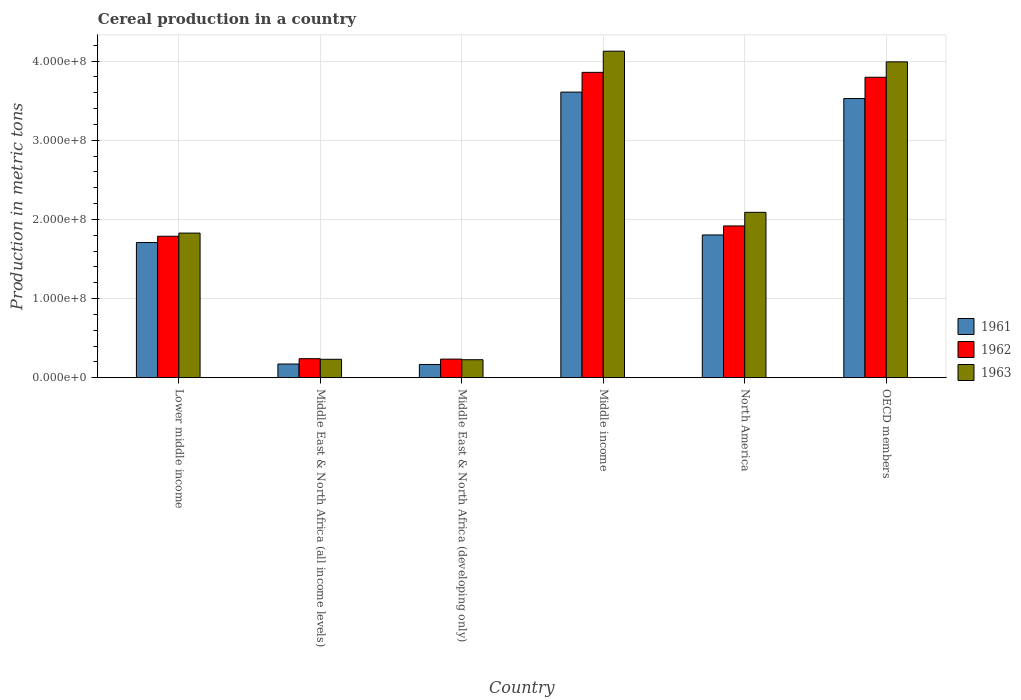How many groups of bars are there?
Provide a succinct answer. 6. Are the number of bars on each tick of the X-axis equal?
Provide a succinct answer. Yes. How many bars are there on the 5th tick from the left?
Your answer should be very brief. 3. What is the total cereal production in 1963 in Middle East & North Africa (all income levels)?
Provide a short and direct response. 2.32e+07. Across all countries, what is the maximum total cereal production in 1963?
Your answer should be compact. 4.13e+08. Across all countries, what is the minimum total cereal production in 1962?
Your response must be concise. 2.35e+07. In which country was the total cereal production in 1961 minimum?
Ensure brevity in your answer.  Middle East & North Africa (developing only). What is the total total cereal production in 1962 in the graph?
Your answer should be very brief. 1.18e+09. What is the difference between the total cereal production in 1963 in Middle East & North Africa (all income levels) and that in Middle East & North Africa (developing only)?
Offer a very short reply. 5.41e+05. What is the difference between the total cereal production in 1962 in Middle East & North Africa (all income levels) and the total cereal production in 1961 in Middle East & North Africa (developing only)?
Ensure brevity in your answer.  7.29e+06. What is the average total cereal production in 1962 per country?
Give a very brief answer. 1.97e+08. What is the difference between the total cereal production of/in 1962 and total cereal production of/in 1963 in Middle East & North Africa (developing only)?
Offer a terse response. 7.80e+05. What is the ratio of the total cereal production in 1963 in Middle East & North Africa (developing only) to that in Middle income?
Provide a succinct answer. 0.05. Is the difference between the total cereal production in 1962 in Middle East & North Africa (all income levels) and Middle East & North Africa (developing only) greater than the difference between the total cereal production in 1963 in Middle East & North Africa (all income levels) and Middle East & North Africa (developing only)?
Make the answer very short. No. What is the difference between the highest and the second highest total cereal production in 1962?
Your answer should be very brief. 6.21e+06. What is the difference between the highest and the lowest total cereal production in 1961?
Your response must be concise. 3.44e+08. In how many countries, is the total cereal production in 1962 greater than the average total cereal production in 1962 taken over all countries?
Provide a succinct answer. 2. Is the sum of the total cereal production in 1962 in Middle East & North Africa (all income levels) and OECD members greater than the maximum total cereal production in 1963 across all countries?
Give a very brief answer. No. What does the 3rd bar from the left in OECD members represents?
Keep it short and to the point. 1963. What does the 2nd bar from the right in Middle East & North Africa (all income levels) represents?
Offer a terse response. 1962. Are all the bars in the graph horizontal?
Ensure brevity in your answer.  No. How many countries are there in the graph?
Ensure brevity in your answer.  6. Does the graph contain grids?
Make the answer very short. Yes. How many legend labels are there?
Ensure brevity in your answer.  3. How are the legend labels stacked?
Provide a short and direct response. Vertical. What is the title of the graph?
Give a very brief answer. Cereal production in a country. What is the label or title of the X-axis?
Provide a short and direct response. Country. What is the label or title of the Y-axis?
Offer a terse response. Production in metric tons. What is the Production in metric tons in 1961 in Lower middle income?
Make the answer very short. 1.71e+08. What is the Production in metric tons in 1962 in Lower middle income?
Provide a short and direct response. 1.79e+08. What is the Production in metric tons in 1963 in Lower middle income?
Give a very brief answer. 1.83e+08. What is the Production in metric tons of 1961 in Middle East & North Africa (all income levels)?
Provide a short and direct response. 1.72e+07. What is the Production in metric tons in 1962 in Middle East & North Africa (all income levels)?
Give a very brief answer. 2.40e+07. What is the Production in metric tons of 1963 in Middle East & North Africa (all income levels)?
Offer a very short reply. 2.32e+07. What is the Production in metric tons of 1961 in Middle East & North Africa (developing only)?
Offer a very short reply. 1.67e+07. What is the Production in metric tons in 1962 in Middle East & North Africa (developing only)?
Keep it short and to the point. 2.35e+07. What is the Production in metric tons of 1963 in Middle East & North Africa (developing only)?
Your response must be concise. 2.27e+07. What is the Production in metric tons in 1961 in Middle income?
Your answer should be compact. 3.61e+08. What is the Production in metric tons of 1962 in Middle income?
Your answer should be compact. 3.86e+08. What is the Production in metric tons in 1963 in Middle income?
Give a very brief answer. 4.13e+08. What is the Production in metric tons in 1961 in North America?
Provide a succinct answer. 1.80e+08. What is the Production in metric tons of 1962 in North America?
Offer a terse response. 1.92e+08. What is the Production in metric tons in 1963 in North America?
Give a very brief answer. 2.09e+08. What is the Production in metric tons in 1961 in OECD members?
Your answer should be compact. 3.53e+08. What is the Production in metric tons in 1962 in OECD members?
Your response must be concise. 3.80e+08. What is the Production in metric tons of 1963 in OECD members?
Offer a terse response. 3.99e+08. Across all countries, what is the maximum Production in metric tons of 1961?
Offer a very short reply. 3.61e+08. Across all countries, what is the maximum Production in metric tons in 1962?
Ensure brevity in your answer.  3.86e+08. Across all countries, what is the maximum Production in metric tons of 1963?
Your answer should be very brief. 4.13e+08. Across all countries, what is the minimum Production in metric tons of 1961?
Provide a short and direct response. 1.67e+07. Across all countries, what is the minimum Production in metric tons in 1962?
Provide a short and direct response. 2.35e+07. Across all countries, what is the minimum Production in metric tons of 1963?
Provide a short and direct response. 2.27e+07. What is the total Production in metric tons of 1961 in the graph?
Your answer should be compact. 1.10e+09. What is the total Production in metric tons of 1962 in the graph?
Provide a short and direct response. 1.18e+09. What is the total Production in metric tons in 1963 in the graph?
Offer a very short reply. 1.25e+09. What is the difference between the Production in metric tons in 1961 in Lower middle income and that in Middle East & North Africa (all income levels)?
Ensure brevity in your answer.  1.54e+08. What is the difference between the Production in metric tons in 1962 in Lower middle income and that in Middle East & North Africa (all income levels)?
Keep it short and to the point. 1.55e+08. What is the difference between the Production in metric tons in 1963 in Lower middle income and that in Middle East & North Africa (all income levels)?
Ensure brevity in your answer.  1.59e+08. What is the difference between the Production in metric tons of 1961 in Lower middle income and that in Middle East & North Africa (developing only)?
Offer a very short reply. 1.54e+08. What is the difference between the Production in metric tons in 1962 in Lower middle income and that in Middle East & North Africa (developing only)?
Offer a terse response. 1.55e+08. What is the difference between the Production in metric tons of 1963 in Lower middle income and that in Middle East & North Africa (developing only)?
Your response must be concise. 1.60e+08. What is the difference between the Production in metric tons in 1961 in Lower middle income and that in Middle income?
Offer a very short reply. -1.90e+08. What is the difference between the Production in metric tons in 1962 in Lower middle income and that in Middle income?
Your answer should be compact. -2.07e+08. What is the difference between the Production in metric tons of 1963 in Lower middle income and that in Middle income?
Your response must be concise. -2.30e+08. What is the difference between the Production in metric tons of 1961 in Lower middle income and that in North America?
Offer a very short reply. -9.59e+06. What is the difference between the Production in metric tons of 1962 in Lower middle income and that in North America?
Your response must be concise. -1.30e+07. What is the difference between the Production in metric tons of 1963 in Lower middle income and that in North America?
Your response must be concise. -2.62e+07. What is the difference between the Production in metric tons in 1961 in Lower middle income and that in OECD members?
Keep it short and to the point. -1.82e+08. What is the difference between the Production in metric tons in 1962 in Lower middle income and that in OECD members?
Give a very brief answer. -2.01e+08. What is the difference between the Production in metric tons in 1963 in Lower middle income and that in OECD members?
Give a very brief answer. -2.16e+08. What is the difference between the Production in metric tons of 1961 in Middle East & North Africa (all income levels) and that in Middle East & North Africa (developing only)?
Your response must be concise. 5.40e+05. What is the difference between the Production in metric tons in 1962 in Middle East & North Africa (all income levels) and that in Middle East & North Africa (developing only)?
Ensure brevity in your answer.  5.21e+05. What is the difference between the Production in metric tons of 1963 in Middle East & North Africa (all income levels) and that in Middle East & North Africa (developing only)?
Provide a short and direct response. 5.41e+05. What is the difference between the Production in metric tons of 1961 in Middle East & North Africa (all income levels) and that in Middle income?
Your answer should be compact. -3.44e+08. What is the difference between the Production in metric tons of 1962 in Middle East & North Africa (all income levels) and that in Middle income?
Your answer should be very brief. -3.62e+08. What is the difference between the Production in metric tons in 1963 in Middle East & North Africa (all income levels) and that in Middle income?
Offer a very short reply. -3.89e+08. What is the difference between the Production in metric tons in 1961 in Middle East & North Africa (all income levels) and that in North America?
Offer a terse response. -1.63e+08. What is the difference between the Production in metric tons in 1962 in Middle East & North Africa (all income levels) and that in North America?
Give a very brief answer. -1.68e+08. What is the difference between the Production in metric tons of 1963 in Middle East & North Africa (all income levels) and that in North America?
Make the answer very short. -1.86e+08. What is the difference between the Production in metric tons of 1961 in Middle East & North Africa (all income levels) and that in OECD members?
Give a very brief answer. -3.35e+08. What is the difference between the Production in metric tons of 1962 in Middle East & North Africa (all income levels) and that in OECD members?
Ensure brevity in your answer.  -3.56e+08. What is the difference between the Production in metric tons in 1963 in Middle East & North Africa (all income levels) and that in OECD members?
Offer a terse response. -3.76e+08. What is the difference between the Production in metric tons in 1961 in Middle East & North Africa (developing only) and that in Middle income?
Your response must be concise. -3.44e+08. What is the difference between the Production in metric tons of 1962 in Middle East & North Africa (developing only) and that in Middle income?
Keep it short and to the point. -3.62e+08. What is the difference between the Production in metric tons in 1963 in Middle East & North Africa (developing only) and that in Middle income?
Provide a short and direct response. -3.90e+08. What is the difference between the Production in metric tons in 1961 in Middle East & North Africa (developing only) and that in North America?
Offer a very short reply. -1.64e+08. What is the difference between the Production in metric tons of 1962 in Middle East & North Africa (developing only) and that in North America?
Keep it short and to the point. -1.68e+08. What is the difference between the Production in metric tons of 1963 in Middle East & North Africa (developing only) and that in North America?
Offer a terse response. -1.86e+08. What is the difference between the Production in metric tons of 1961 in Middle East & North Africa (developing only) and that in OECD members?
Make the answer very short. -3.36e+08. What is the difference between the Production in metric tons of 1962 in Middle East & North Africa (developing only) and that in OECD members?
Ensure brevity in your answer.  -3.56e+08. What is the difference between the Production in metric tons of 1963 in Middle East & North Africa (developing only) and that in OECD members?
Your response must be concise. -3.76e+08. What is the difference between the Production in metric tons in 1961 in Middle income and that in North America?
Offer a very short reply. 1.81e+08. What is the difference between the Production in metric tons in 1962 in Middle income and that in North America?
Give a very brief answer. 1.94e+08. What is the difference between the Production in metric tons in 1963 in Middle income and that in North America?
Offer a very short reply. 2.04e+08. What is the difference between the Production in metric tons in 1961 in Middle income and that in OECD members?
Provide a short and direct response. 8.13e+06. What is the difference between the Production in metric tons of 1962 in Middle income and that in OECD members?
Your answer should be very brief. 6.21e+06. What is the difference between the Production in metric tons of 1963 in Middle income and that in OECD members?
Keep it short and to the point. 1.35e+07. What is the difference between the Production in metric tons of 1961 in North America and that in OECD members?
Offer a terse response. -1.72e+08. What is the difference between the Production in metric tons in 1962 in North America and that in OECD members?
Give a very brief answer. -1.88e+08. What is the difference between the Production in metric tons in 1963 in North America and that in OECD members?
Your answer should be very brief. -1.90e+08. What is the difference between the Production in metric tons of 1961 in Lower middle income and the Production in metric tons of 1962 in Middle East & North Africa (all income levels)?
Offer a terse response. 1.47e+08. What is the difference between the Production in metric tons in 1961 in Lower middle income and the Production in metric tons in 1963 in Middle East & North Africa (all income levels)?
Your answer should be compact. 1.48e+08. What is the difference between the Production in metric tons of 1962 in Lower middle income and the Production in metric tons of 1963 in Middle East & North Africa (all income levels)?
Provide a succinct answer. 1.55e+08. What is the difference between the Production in metric tons of 1961 in Lower middle income and the Production in metric tons of 1962 in Middle East & North Africa (developing only)?
Provide a short and direct response. 1.47e+08. What is the difference between the Production in metric tons of 1961 in Lower middle income and the Production in metric tons of 1963 in Middle East & North Africa (developing only)?
Give a very brief answer. 1.48e+08. What is the difference between the Production in metric tons of 1962 in Lower middle income and the Production in metric tons of 1963 in Middle East & North Africa (developing only)?
Your answer should be compact. 1.56e+08. What is the difference between the Production in metric tons of 1961 in Lower middle income and the Production in metric tons of 1962 in Middle income?
Offer a very short reply. -2.15e+08. What is the difference between the Production in metric tons in 1961 in Lower middle income and the Production in metric tons in 1963 in Middle income?
Provide a succinct answer. -2.42e+08. What is the difference between the Production in metric tons of 1962 in Lower middle income and the Production in metric tons of 1963 in Middle income?
Make the answer very short. -2.34e+08. What is the difference between the Production in metric tons in 1961 in Lower middle income and the Production in metric tons in 1962 in North America?
Your answer should be compact. -2.10e+07. What is the difference between the Production in metric tons of 1961 in Lower middle income and the Production in metric tons of 1963 in North America?
Your answer should be compact. -3.82e+07. What is the difference between the Production in metric tons in 1962 in Lower middle income and the Production in metric tons in 1963 in North America?
Your answer should be very brief. -3.02e+07. What is the difference between the Production in metric tons of 1961 in Lower middle income and the Production in metric tons of 1962 in OECD members?
Your answer should be very brief. -2.09e+08. What is the difference between the Production in metric tons in 1961 in Lower middle income and the Production in metric tons in 1963 in OECD members?
Your answer should be compact. -2.28e+08. What is the difference between the Production in metric tons in 1962 in Lower middle income and the Production in metric tons in 1963 in OECD members?
Keep it short and to the point. -2.20e+08. What is the difference between the Production in metric tons in 1961 in Middle East & North Africa (all income levels) and the Production in metric tons in 1962 in Middle East & North Africa (developing only)?
Ensure brevity in your answer.  -6.23e+06. What is the difference between the Production in metric tons of 1961 in Middle East & North Africa (all income levels) and the Production in metric tons of 1963 in Middle East & North Africa (developing only)?
Your answer should be very brief. -5.45e+06. What is the difference between the Production in metric tons of 1962 in Middle East & North Africa (all income levels) and the Production in metric tons of 1963 in Middle East & North Africa (developing only)?
Provide a succinct answer. 1.30e+06. What is the difference between the Production in metric tons of 1961 in Middle East & North Africa (all income levels) and the Production in metric tons of 1962 in Middle income?
Ensure brevity in your answer.  -3.69e+08. What is the difference between the Production in metric tons in 1961 in Middle East & North Africa (all income levels) and the Production in metric tons in 1963 in Middle income?
Make the answer very short. -3.95e+08. What is the difference between the Production in metric tons of 1962 in Middle East & North Africa (all income levels) and the Production in metric tons of 1963 in Middle income?
Provide a short and direct response. -3.89e+08. What is the difference between the Production in metric tons of 1961 in Middle East & North Africa (all income levels) and the Production in metric tons of 1962 in North America?
Your answer should be very brief. -1.74e+08. What is the difference between the Production in metric tons in 1961 in Middle East & North Africa (all income levels) and the Production in metric tons in 1963 in North America?
Make the answer very short. -1.92e+08. What is the difference between the Production in metric tons in 1962 in Middle East & North Africa (all income levels) and the Production in metric tons in 1963 in North America?
Offer a very short reply. -1.85e+08. What is the difference between the Production in metric tons in 1961 in Middle East & North Africa (all income levels) and the Production in metric tons in 1962 in OECD members?
Your response must be concise. -3.62e+08. What is the difference between the Production in metric tons in 1961 in Middle East & North Africa (all income levels) and the Production in metric tons in 1963 in OECD members?
Provide a short and direct response. -3.82e+08. What is the difference between the Production in metric tons of 1962 in Middle East & North Africa (all income levels) and the Production in metric tons of 1963 in OECD members?
Provide a succinct answer. -3.75e+08. What is the difference between the Production in metric tons in 1961 in Middle East & North Africa (developing only) and the Production in metric tons in 1962 in Middle income?
Ensure brevity in your answer.  -3.69e+08. What is the difference between the Production in metric tons in 1961 in Middle East & North Africa (developing only) and the Production in metric tons in 1963 in Middle income?
Make the answer very short. -3.96e+08. What is the difference between the Production in metric tons of 1962 in Middle East & North Africa (developing only) and the Production in metric tons of 1963 in Middle income?
Your answer should be compact. -3.89e+08. What is the difference between the Production in metric tons of 1961 in Middle East & North Africa (developing only) and the Production in metric tons of 1962 in North America?
Ensure brevity in your answer.  -1.75e+08. What is the difference between the Production in metric tons in 1961 in Middle East & North Africa (developing only) and the Production in metric tons in 1963 in North America?
Your answer should be very brief. -1.92e+08. What is the difference between the Production in metric tons in 1962 in Middle East & North Africa (developing only) and the Production in metric tons in 1963 in North America?
Your answer should be compact. -1.85e+08. What is the difference between the Production in metric tons in 1961 in Middle East & North Africa (developing only) and the Production in metric tons in 1962 in OECD members?
Provide a succinct answer. -3.63e+08. What is the difference between the Production in metric tons of 1961 in Middle East & North Africa (developing only) and the Production in metric tons of 1963 in OECD members?
Provide a short and direct response. -3.82e+08. What is the difference between the Production in metric tons of 1962 in Middle East & North Africa (developing only) and the Production in metric tons of 1963 in OECD members?
Ensure brevity in your answer.  -3.76e+08. What is the difference between the Production in metric tons of 1961 in Middle income and the Production in metric tons of 1962 in North America?
Offer a terse response. 1.69e+08. What is the difference between the Production in metric tons of 1961 in Middle income and the Production in metric tons of 1963 in North America?
Give a very brief answer. 1.52e+08. What is the difference between the Production in metric tons of 1962 in Middle income and the Production in metric tons of 1963 in North America?
Give a very brief answer. 1.77e+08. What is the difference between the Production in metric tons of 1961 in Middle income and the Production in metric tons of 1962 in OECD members?
Provide a succinct answer. -1.88e+07. What is the difference between the Production in metric tons in 1961 in Middle income and the Production in metric tons in 1963 in OECD members?
Offer a terse response. -3.82e+07. What is the difference between the Production in metric tons in 1962 in Middle income and the Production in metric tons in 1963 in OECD members?
Offer a very short reply. -1.32e+07. What is the difference between the Production in metric tons in 1961 in North America and the Production in metric tons in 1962 in OECD members?
Offer a very short reply. -1.99e+08. What is the difference between the Production in metric tons of 1961 in North America and the Production in metric tons of 1963 in OECD members?
Keep it short and to the point. -2.19e+08. What is the difference between the Production in metric tons of 1962 in North America and the Production in metric tons of 1963 in OECD members?
Your answer should be compact. -2.07e+08. What is the average Production in metric tons of 1961 per country?
Ensure brevity in your answer.  1.83e+08. What is the average Production in metric tons of 1962 per country?
Keep it short and to the point. 1.97e+08. What is the average Production in metric tons in 1963 per country?
Make the answer very short. 2.08e+08. What is the difference between the Production in metric tons of 1961 and Production in metric tons of 1962 in Lower middle income?
Make the answer very short. -7.94e+06. What is the difference between the Production in metric tons in 1961 and Production in metric tons in 1963 in Lower middle income?
Provide a short and direct response. -1.19e+07. What is the difference between the Production in metric tons in 1962 and Production in metric tons in 1963 in Lower middle income?
Make the answer very short. -4.00e+06. What is the difference between the Production in metric tons in 1961 and Production in metric tons in 1962 in Middle East & North Africa (all income levels)?
Provide a short and direct response. -6.75e+06. What is the difference between the Production in metric tons of 1961 and Production in metric tons of 1963 in Middle East & North Africa (all income levels)?
Make the answer very short. -5.99e+06. What is the difference between the Production in metric tons of 1962 and Production in metric tons of 1963 in Middle East & North Africa (all income levels)?
Offer a very short reply. 7.60e+05. What is the difference between the Production in metric tons of 1961 and Production in metric tons of 1962 in Middle East & North Africa (developing only)?
Give a very brief answer. -6.77e+06. What is the difference between the Production in metric tons in 1961 and Production in metric tons in 1963 in Middle East & North Africa (developing only)?
Keep it short and to the point. -5.99e+06. What is the difference between the Production in metric tons of 1962 and Production in metric tons of 1963 in Middle East & North Africa (developing only)?
Your response must be concise. 7.80e+05. What is the difference between the Production in metric tons in 1961 and Production in metric tons in 1962 in Middle income?
Offer a terse response. -2.50e+07. What is the difference between the Production in metric tons in 1961 and Production in metric tons in 1963 in Middle income?
Make the answer very short. -5.17e+07. What is the difference between the Production in metric tons of 1962 and Production in metric tons of 1963 in Middle income?
Provide a succinct answer. -2.67e+07. What is the difference between the Production in metric tons in 1961 and Production in metric tons in 1962 in North America?
Ensure brevity in your answer.  -1.14e+07. What is the difference between the Production in metric tons in 1961 and Production in metric tons in 1963 in North America?
Your response must be concise. -2.86e+07. What is the difference between the Production in metric tons of 1962 and Production in metric tons of 1963 in North America?
Provide a succinct answer. -1.72e+07. What is the difference between the Production in metric tons in 1961 and Production in metric tons in 1962 in OECD members?
Provide a short and direct response. -2.69e+07. What is the difference between the Production in metric tons in 1961 and Production in metric tons in 1963 in OECD members?
Your answer should be very brief. -4.63e+07. What is the difference between the Production in metric tons of 1962 and Production in metric tons of 1963 in OECD members?
Your answer should be very brief. -1.94e+07. What is the ratio of the Production in metric tons in 1961 in Lower middle income to that in Middle East & North Africa (all income levels)?
Provide a short and direct response. 9.91. What is the ratio of the Production in metric tons in 1962 in Lower middle income to that in Middle East & North Africa (all income levels)?
Provide a short and direct response. 7.45. What is the ratio of the Production in metric tons of 1963 in Lower middle income to that in Middle East & North Africa (all income levels)?
Provide a short and direct response. 7.87. What is the ratio of the Production in metric tons in 1961 in Lower middle income to that in Middle East & North Africa (developing only)?
Your answer should be compact. 10.23. What is the ratio of the Production in metric tons in 1962 in Lower middle income to that in Middle East & North Africa (developing only)?
Ensure brevity in your answer.  7.62. What is the ratio of the Production in metric tons of 1963 in Lower middle income to that in Middle East & North Africa (developing only)?
Keep it short and to the point. 8.06. What is the ratio of the Production in metric tons in 1961 in Lower middle income to that in Middle income?
Offer a very short reply. 0.47. What is the ratio of the Production in metric tons of 1962 in Lower middle income to that in Middle income?
Your answer should be very brief. 0.46. What is the ratio of the Production in metric tons of 1963 in Lower middle income to that in Middle income?
Ensure brevity in your answer.  0.44. What is the ratio of the Production in metric tons of 1961 in Lower middle income to that in North America?
Provide a succinct answer. 0.95. What is the ratio of the Production in metric tons in 1962 in Lower middle income to that in North America?
Offer a very short reply. 0.93. What is the ratio of the Production in metric tons of 1963 in Lower middle income to that in North America?
Give a very brief answer. 0.87. What is the ratio of the Production in metric tons of 1961 in Lower middle income to that in OECD members?
Provide a short and direct response. 0.48. What is the ratio of the Production in metric tons of 1962 in Lower middle income to that in OECD members?
Offer a very short reply. 0.47. What is the ratio of the Production in metric tons in 1963 in Lower middle income to that in OECD members?
Provide a succinct answer. 0.46. What is the ratio of the Production in metric tons in 1961 in Middle East & North Africa (all income levels) to that in Middle East & North Africa (developing only)?
Offer a very short reply. 1.03. What is the ratio of the Production in metric tons of 1962 in Middle East & North Africa (all income levels) to that in Middle East & North Africa (developing only)?
Provide a succinct answer. 1.02. What is the ratio of the Production in metric tons in 1963 in Middle East & North Africa (all income levels) to that in Middle East & North Africa (developing only)?
Keep it short and to the point. 1.02. What is the ratio of the Production in metric tons of 1961 in Middle East & North Africa (all income levels) to that in Middle income?
Your answer should be very brief. 0.05. What is the ratio of the Production in metric tons in 1962 in Middle East & North Africa (all income levels) to that in Middle income?
Your answer should be compact. 0.06. What is the ratio of the Production in metric tons in 1963 in Middle East & North Africa (all income levels) to that in Middle income?
Give a very brief answer. 0.06. What is the ratio of the Production in metric tons in 1961 in Middle East & North Africa (all income levels) to that in North America?
Provide a short and direct response. 0.1. What is the ratio of the Production in metric tons in 1962 in Middle East & North Africa (all income levels) to that in North America?
Provide a succinct answer. 0.13. What is the ratio of the Production in metric tons of 1961 in Middle East & North Africa (all income levels) to that in OECD members?
Make the answer very short. 0.05. What is the ratio of the Production in metric tons of 1962 in Middle East & North Africa (all income levels) to that in OECD members?
Your response must be concise. 0.06. What is the ratio of the Production in metric tons in 1963 in Middle East & North Africa (all income levels) to that in OECD members?
Make the answer very short. 0.06. What is the ratio of the Production in metric tons in 1961 in Middle East & North Africa (developing only) to that in Middle income?
Your answer should be compact. 0.05. What is the ratio of the Production in metric tons of 1962 in Middle East & North Africa (developing only) to that in Middle income?
Your answer should be very brief. 0.06. What is the ratio of the Production in metric tons in 1963 in Middle East & North Africa (developing only) to that in Middle income?
Offer a very short reply. 0.06. What is the ratio of the Production in metric tons of 1961 in Middle East & North Africa (developing only) to that in North America?
Your response must be concise. 0.09. What is the ratio of the Production in metric tons in 1962 in Middle East & North Africa (developing only) to that in North America?
Your answer should be very brief. 0.12. What is the ratio of the Production in metric tons of 1963 in Middle East & North Africa (developing only) to that in North America?
Provide a succinct answer. 0.11. What is the ratio of the Production in metric tons of 1961 in Middle East & North Africa (developing only) to that in OECD members?
Offer a very short reply. 0.05. What is the ratio of the Production in metric tons of 1962 in Middle East & North Africa (developing only) to that in OECD members?
Ensure brevity in your answer.  0.06. What is the ratio of the Production in metric tons in 1963 in Middle East & North Africa (developing only) to that in OECD members?
Make the answer very short. 0.06. What is the ratio of the Production in metric tons of 1961 in Middle income to that in North America?
Provide a short and direct response. 2. What is the ratio of the Production in metric tons in 1962 in Middle income to that in North America?
Give a very brief answer. 2.01. What is the ratio of the Production in metric tons in 1963 in Middle income to that in North America?
Provide a short and direct response. 1.97. What is the ratio of the Production in metric tons in 1962 in Middle income to that in OECD members?
Keep it short and to the point. 1.02. What is the ratio of the Production in metric tons in 1963 in Middle income to that in OECD members?
Provide a succinct answer. 1.03. What is the ratio of the Production in metric tons in 1961 in North America to that in OECD members?
Your answer should be compact. 0.51. What is the ratio of the Production in metric tons in 1962 in North America to that in OECD members?
Provide a short and direct response. 0.51. What is the ratio of the Production in metric tons in 1963 in North America to that in OECD members?
Ensure brevity in your answer.  0.52. What is the difference between the highest and the second highest Production in metric tons of 1961?
Offer a terse response. 8.13e+06. What is the difference between the highest and the second highest Production in metric tons in 1962?
Ensure brevity in your answer.  6.21e+06. What is the difference between the highest and the second highest Production in metric tons of 1963?
Your response must be concise. 1.35e+07. What is the difference between the highest and the lowest Production in metric tons of 1961?
Offer a very short reply. 3.44e+08. What is the difference between the highest and the lowest Production in metric tons of 1962?
Your response must be concise. 3.62e+08. What is the difference between the highest and the lowest Production in metric tons of 1963?
Provide a short and direct response. 3.90e+08. 